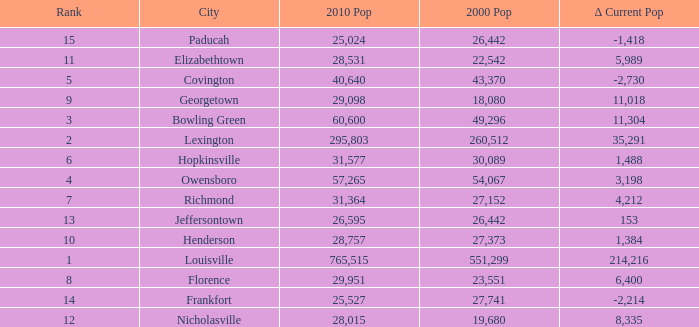What was the 2010 population of frankfort which has a rank smaller than 14? None. 